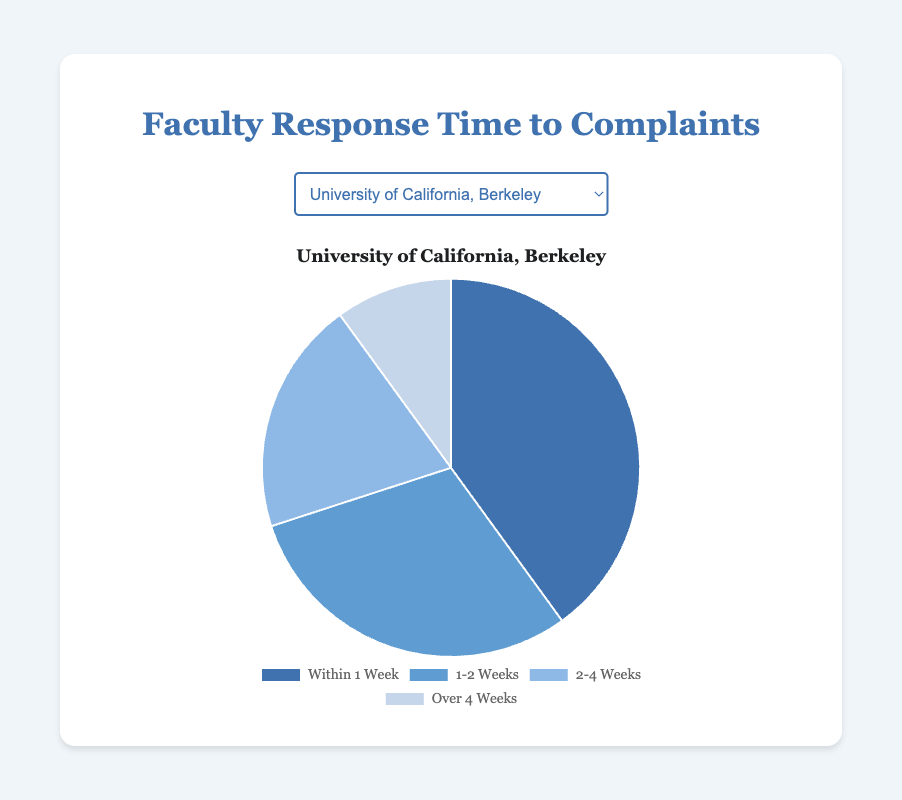What proportion of responses occur within 1-2 weeks at Harvard University compared to the total responses? To find the proportion, add up all the response times for Harvard University (35 + 25 + 30 + 10 = 100). Then divide the number of responses within 1-2 weeks by this total (25/100 = 0.25 or 25%).
Answer: 25% Which university takes the longest on average to respond to complaints? Calculate the average response time over the four categories for each university and compare them. Sum each university’s responses and divide by 4. For MIT: (45 + 30 + 20 + 5) / 4 = 25, Stanford: (30 + 35 + 25 + 10) / 4 = 25, Harvard: (35 + 25 + 30 + 10) / 4 = 25, UC Berkeley: (40 + 30 + 20 + 10) / 4 = 25. All universities have an average of 25 days.
Answer: All universities are equal How many more complaints are resolved within 1 week at MIT compared to Stanford? Subtract the number of complaints resolved within 1 week at Stanford from those at MIT. (45 - 30) = 15.
Answer: 15 What is the dominant color in the pie chart for responses at UC Berkeley? Since UC Berkeley's highest value is for responses within 1 week (40), look at the color used for this segment which is blue.
Answer: Blue Compare the number of complaints resolved in 1-2 weeks and those resolved over 4 weeks at Stanford University. Which is greater and by how much? Compare the values directly for Stanford (35 for 1-2 weeks and 10 for over 4 weeks). The difference is (35 - 10) = 25.
Answer: 1-2 weeks by 25 What is the combined percentage of complaints resolved within 1 week and over 4 weeks at University of California, Berkeley? Sum the number of complaints within 1 week and over 4 weeks (40 + 10 = 50) at UC Berkeley. The total complaints are 100, so the combined percentage is (50/100) * 100 = 50%.
Answer: 50% Which university resolves fewer complaints in the 2-4 weeks category than Harvard University? Compare universities’ 2-4 weeks segment: MIT (20) and Stanford (25) both have fewer complaints in this category than Harvard (30).
Answer: MIT, Stanford 